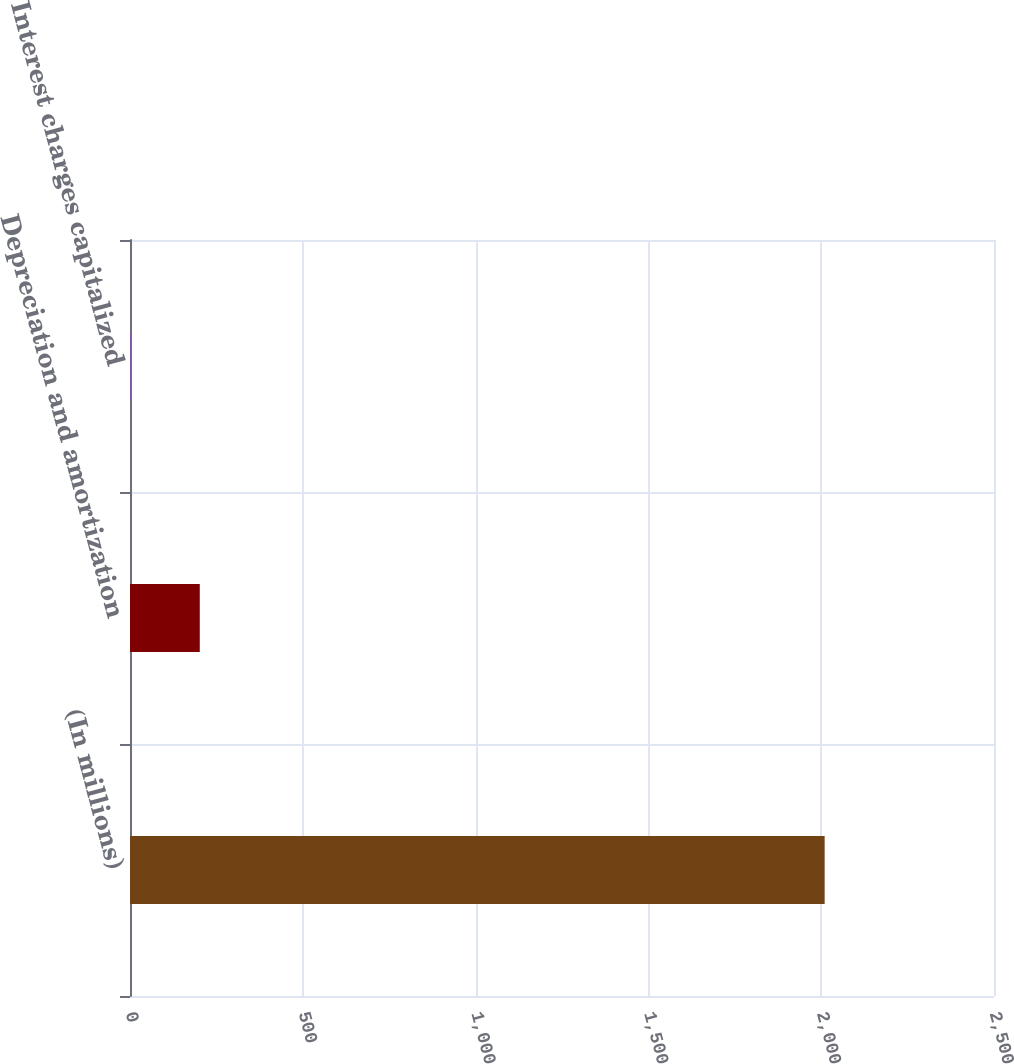Convert chart. <chart><loc_0><loc_0><loc_500><loc_500><bar_chart><fcel>(In millions)<fcel>Depreciation and amortization<fcel>Interest charges capitalized<nl><fcel>2010<fcel>201.9<fcel>1<nl></chart> 